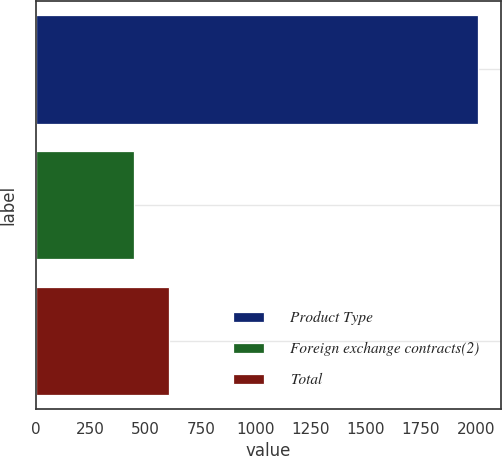<chart> <loc_0><loc_0><loc_500><loc_500><bar_chart><fcel>Product Type<fcel>Foreign exchange contracts(2)<fcel>Total<nl><fcel>2013<fcel>448<fcel>604.5<nl></chart> 